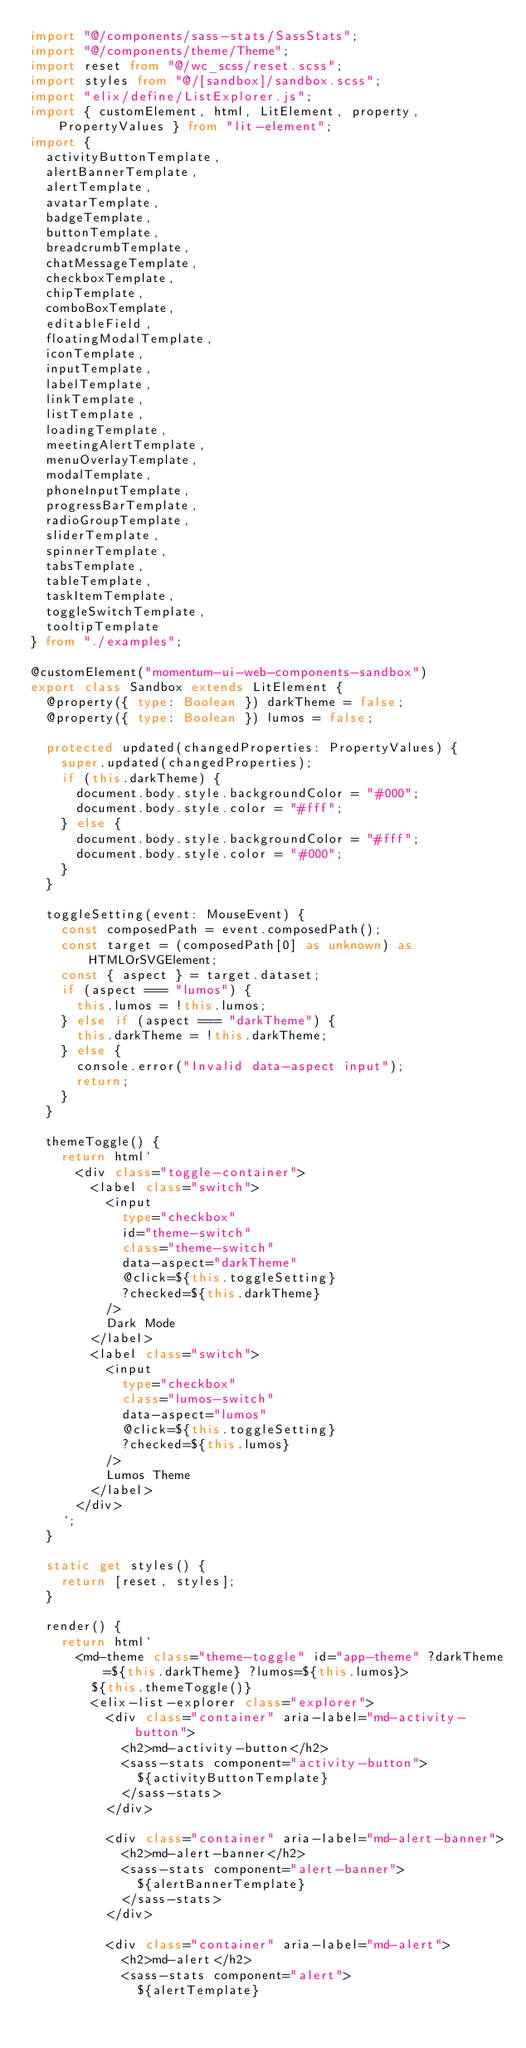Convert code to text. <code><loc_0><loc_0><loc_500><loc_500><_TypeScript_>import "@/components/sass-stats/SassStats";
import "@/components/theme/Theme";
import reset from "@/wc_scss/reset.scss";
import styles from "@/[sandbox]/sandbox.scss";
import "elix/define/ListExplorer.js";
import { customElement, html, LitElement, property, PropertyValues } from "lit-element";
import {
  activityButtonTemplate,
  alertBannerTemplate,
  alertTemplate,
  avatarTemplate,
  badgeTemplate,
  buttonTemplate,
  breadcrumbTemplate,
  chatMessageTemplate,
  checkboxTemplate,
  chipTemplate,
  comboBoxTemplate,
  editableField,
  floatingModalTemplate,
  iconTemplate,
  inputTemplate,
  labelTemplate,
  linkTemplate,
  listTemplate,
  loadingTemplate,
  meetingAlertTemplate,
  menuOverlayTemplate,
  modalTemplate,
  phoneInputTemplate,
  progressBarTemplate,
  radioGroupTemplate,
  sliderTemplate,
  spinnerTemplate,
  tabsTemplate,
  tableTemplate,
  taskItemTemplate,
  toggleSwitchTemplate,
  tooltipTemplate
} from "./examples";

@customElement("momentum-ui-web-components-sandbox")
export class Sandbox extends LitElement {
  @property({ type: Boolean }) darkTheme = false;
  @property({ type: Boolean }) lumos = false;

  protected updated(changedProperties: PropertyValues) {
    super.updated(changedProperties);
    if (this.darkTheme) {
      document.body.style.backgroundColor = "#000";
      document.body.style.color = "#fff";
    } else {
      document.body.style.backgroundColor = "#fff";
      document.body.style.color = "#000";
    }
  }

  toggleSetting(event: MouseEvent) {
    const composedPath = event.composedPath();
    const target = (composedPath[0] as unknown) as HTMLOrSVGElement;
    const { aspect } = target.dataset;
    if (aspect === "lumos") {
      this.lumos = !this.lumos;
    } else if (aspect === "darkTheme") {
      this.darkTheme = !this.darkTheme;
    } else {
      console.error("Invalid data-aspect input");
      return;
    }
  }

  themeToggle() {
    return html`
      <div class="toggle-container">
        <label class="switch">
          <input
            type="checkbox"
            id="theme-switch"
            class="theme-switch"
            data-aspect="darkTheme"
            @click=${this.toggleSetting}
            ?checked=${this.darkTheme}
          />
          Dark Mode
        </label>
        <label class="switch">
          <input
            type="checkbox"
            class="lumos-switch"
            data-aspect="lumos"
            @click=${this.toggleSetting}
            ?checked=${this.lumos}
          />
          Lumos Theme
        </label>
      </div>
    `;
  }

  static get styles() {
    return [reset, styles];
  }

  render() {
    return html`
      <md-theme class="theme-toggle" id="app-theme" ?darkTheme=${this.darkTheme} ?lumos=${this.lumos}>
        ${this.themeToggle()}
        <elix-list-explorer class="explorer">
          <div class="container" aria-label="md-activity-button">
            <h2>md-activity-button</h2>
            <sass-stats component="activity-button">
              ${activityButtonTemplate}
            </sass-stats>
          </div>

          <div class="container" aria-label="md-alert-banner">
            <h2>md-alert-banner</h2>
            <sass-stats component="alert-banner">
              ${alertBannerTemplate}
            </sass-stats>
          </div>

          <div class="container" aria-label="md-alert">
            <h2>md-alert</h2>
            <sass-stats component="alert">
              ${alertTemplate}</code> 